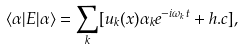Convert formula to latex. <formula><loc_0><loc_0><loc_500><loc_500>\langle \alpha | E | \alpha \rangle = \sum _ { k } [ u _ { k } ( x ) \alpha _ { k } e ^ { - i \omega _ { k } t } + h . c ] ,</formula> 